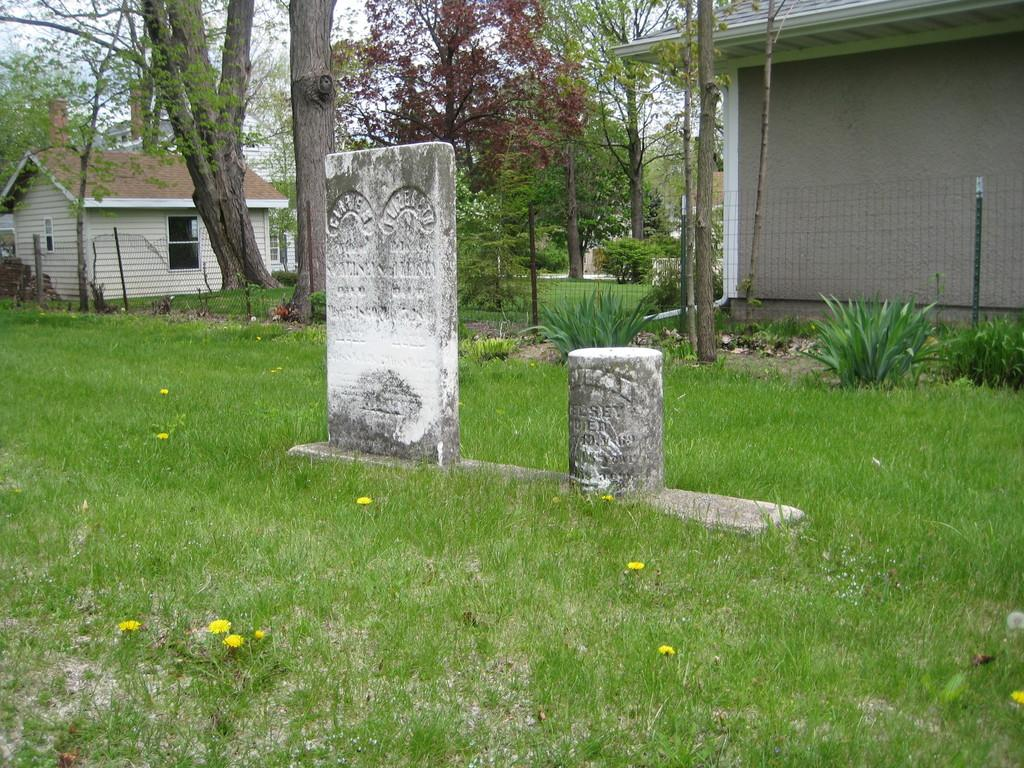What type of structures are present in the image? There are tombstones in the image. Where are the tombstones located? The tombstones are on a grassland. What is the purpose of the fence in the image? The fence is present in the image to enclose the area. What can be seen behind the fence? Trees are visible behind the fence. What type of buildings are on either side of the image? There are two buildings on either side of the image. What type of glove is being worn by the minister in the image? There is no minister or glove present in the image. 